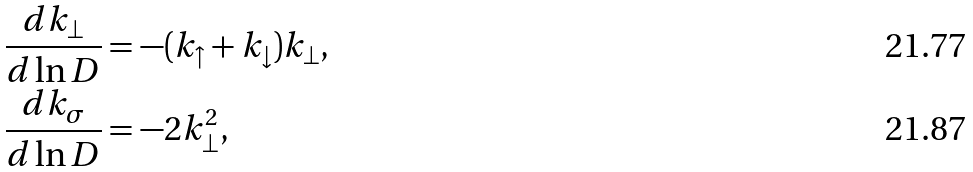Convert formula to latex. <formula><loc_0><loc_0><loc_500><loc_500>& \frac { d k _ { \perp } } { d \ln D } = - ( k _ { \uparrow } + k _ { \downarrow } ) k _ { \perp } , \\ & \frac { d k _ { \sigma } } { d \ln D } = - 2 k _ { \perp } ^ { 2 } ,</formula> 